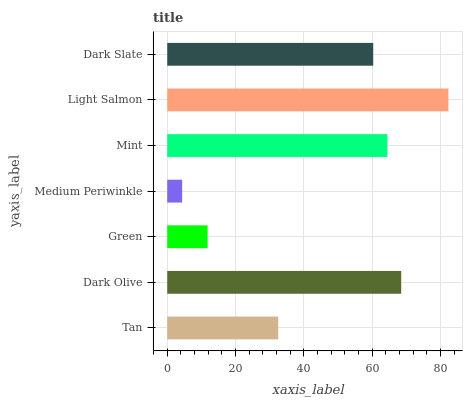Is Medium Periwinkle the minimum?
Answer yes or no. Yes. Is Light Salmon the maximum?
Answer yes or no. Yes. Is Dark Olive the minimum?
Answer yes or no. No. Is Dark Olive the maximum?
Answer yes or no. No. Is Dark Olive greater than Tan?
Answer yes or no. Yes. Is Tan less than Dark Olive?
Answer yes or no. Yes. Is Tan greater than Dark Olive?
Answer yes or no. No. Is Dark Olive less than Tan?
Answer yes or no. No. Is Dark Slate the high median?
Answer yes or no. Yes. Is Dark Slate the low median?
Answer yes or no. Yes. Is Mint the high median?
Answer yes or no. No. Is Green the low median?
Answer yes or no. No. 